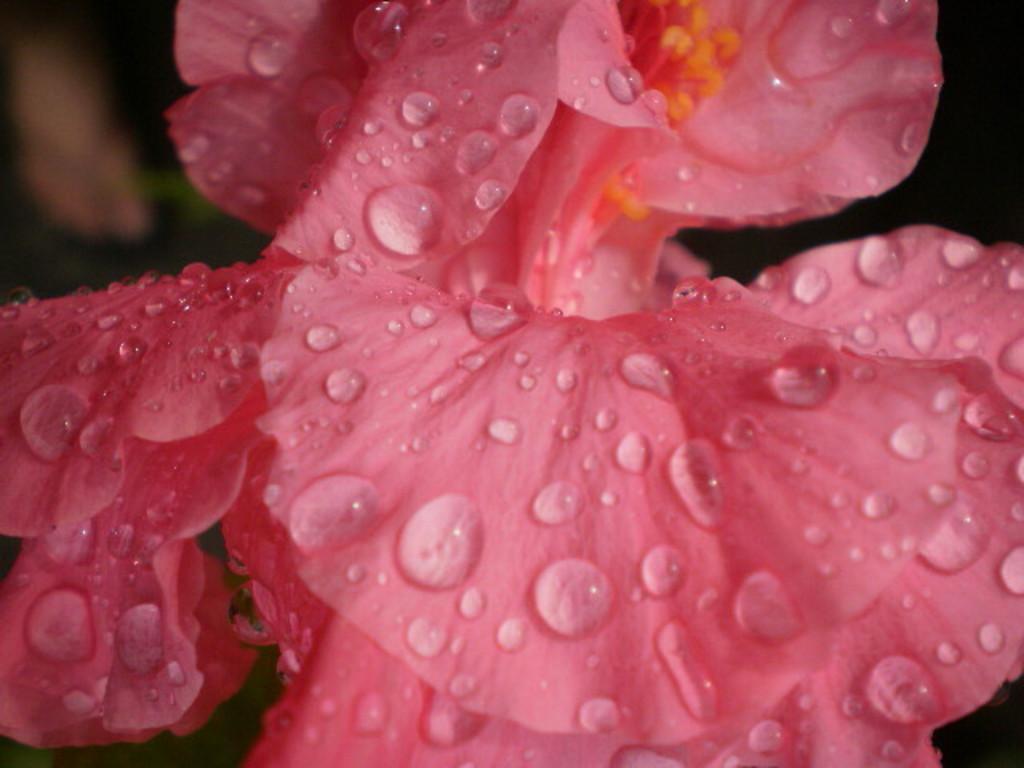In one or two sentences, can you explain what this image depicts? In this image I can see a pink color flower. The background is dark in color. This image is taken may be during night. 